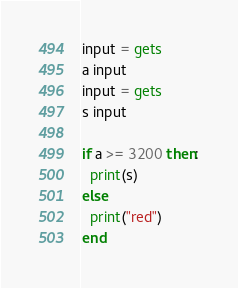<code> <loc_0><loc_0><loc_500><loc_500><_Ruby_>input = gets
a input
input = gets
s input

if a >= 3200 then:
  print(s)
else
  print("red")
end</code> 